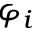<formula> <loc_0><loc_0><loc_500><loc_500>\varphi _ { i }</formula> 